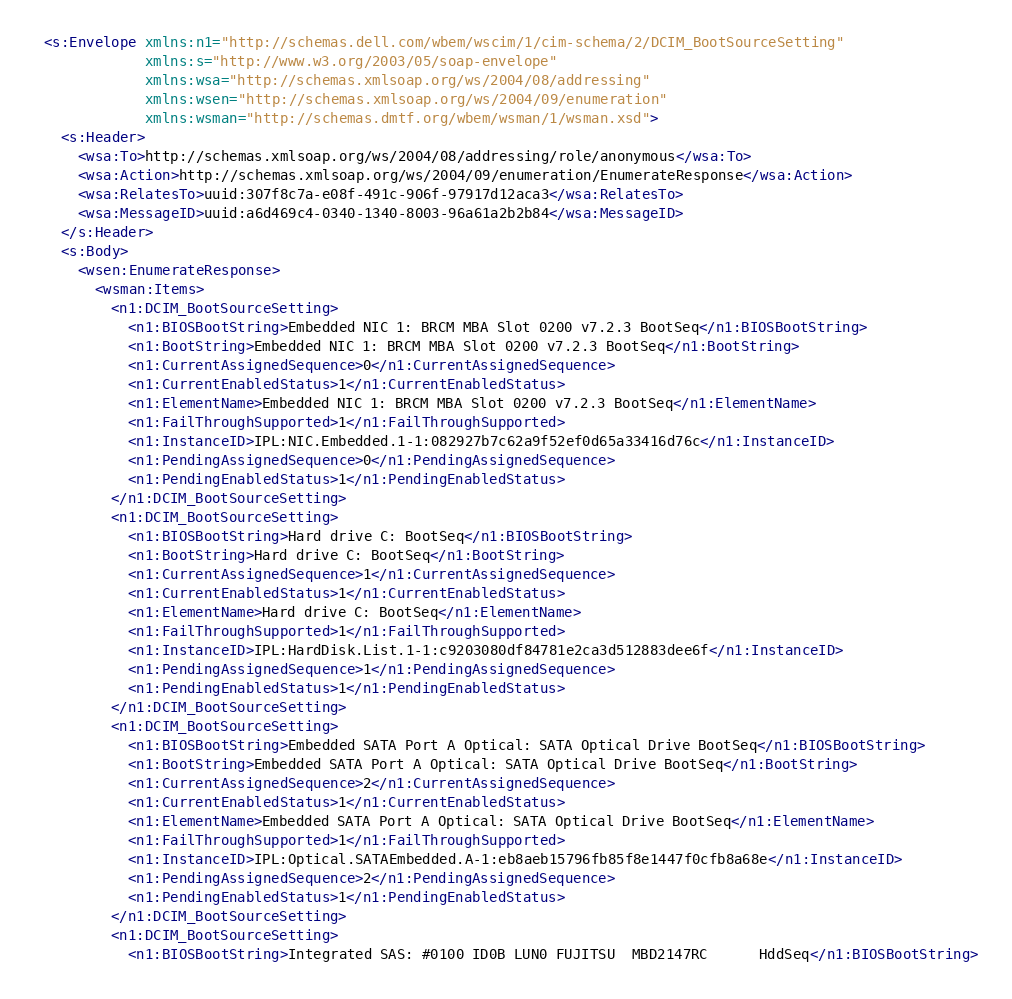<code> <loc_0><loc_0><loc_500><loc_500><_XML_><s:Envelope xmlns:n1="http://schemas.dell.com/wbem/wscim/1/cim-schema/2/DCIM_BootSourceSetting"
            xmlns:s="http://www.w3.org/2003/05/soap-envelope"
            xmlns:wsa="http://schemas.xmlsoap.org/ws/2004/08/addressing"
            xmlns:wsen="http://schemas.xmlsoap.org/ws/2004/09/enumeration"
            xmlns:wsman="http://schemas.dmtf.org/wbem/wsman/1/wsman.xsd">
  <s:Header>
    <wsa:To>http://schemas.xmlsoap.org/ws/2004/08/addressing/role/anonymous</wsa:To>
    <wsa:Action>http://schemas.xmlsoap.org/ws/2004/09/enumeration/EnumerateResponse</wsa:Action>
    <wsa:RelatesTo>uuid:307f8c7a-e08f-491c-906f-97917d12aca3</wsa:RelatesTo>
    <wsa:MessageID>uuid:a6d469c4-0340-1340-8003-96a61a2b2b84</wsa:MessageID>
  </s:Header>
  <s:Body>
    <wsen:EnumerateResponse>
      <wsman:Items>
        <n1:DCIM_BootSourceSetting>
          <n1:BIOSBootString>Embedded NIC 1: BRCM MBA Slot 0200 v7.2.3 BootSeq</n1:BIOSBootString>
          <n1:BootString>Embedded NIC 1: BRCM MBA Slot 0200 v7.2.3 BootSeq</n1:BootString>
          <n1:CurrentAssignedSequence>0</n1:CurrentAssignedSequence>
          <n1:CurrentEnabledStatus>1</n1:CurrentEnabledStatus>
          <n1:ElementName>Embedded NIC 1: BRCM MBA Slot 0200 v7.2.3 BootSeq</n1:ElementName>
          <n1:FailThroughSupported>1</n1:FailThroughSupported>
          <n1:InstanceID>IPL:NIC.Embedded.1-1:082927b7c62a9f52ef0d65a33416d76c</n1:InstanceID>
          <n1:PendingAssignedSequence>0</n1:PendingAssignedSequence>
          <n1:PendingEnabledStatus>1</n1:PendingEnabledStatus>
        </n1:DCIM_BootSourceSetting>
        <n1:DCIM_BootSourceSetting>
          <n1:BIOSBootString>Hard drive C: BootSeq</n1:BIOSBootString>
          <n1:BootString>Hard drive C: BootSeq</n1:BootString>
          <n1:CurrentAssignedSequence>1</n1:CurrentAssignedSequence>
          <n1:CurrentEnabledStatus>1</n1:CurrentEnabledStatus>
          <n1:ElementName>Hard drive C: BootSeq</n1:ElementName>
          <n1:FailThroughSupported>1</n1:FailThroughSupported>
          <n1:InstanceID>IPL:HardDisk.List.1-1:c9203080df84781e2ca3d512883dee6f</n1:InstanceID>
          <n1:PendingAssignedSequence>1</n1:PendingAssignedSequence>
          <n1:PendingEnabledStatus>1</n1:PendingEnabledStatus>
        </n1:DCIM_BootSourceSetting>
        <n1:DCIM_BootSourceSetting>
          <n1:BIOSBootString>Embedded SATA Port A Optical: SATA Optical Drive BootSeq</n1:BIOSBootString>
          <n1:BootString>Embedded SATA Port A Optical: SATA Optical Drive BootSeq</n1:BootString>
          <n1:CurrentAssignedSequence>2</n1:CurrentAssignedSequence>
          <n1:CurrentEnabledStatus>1</n1:CurrentEnabledStatus>
          <n1:ElementName>Embedded SATA Port A Optical: SATA Optical Drive BootSeq</n1:ElementName>
          <n1:FailThroughSupported>1</n1:FailThroughSupported>
          <n1:InstanceID>IPL:Optical.SATAEmbedded.A-1:eb8aeb15796fb85f8e1447f0cfb8a68e</n1:InstanceID>
          <n1:PendingAssignedSequence>2</n1:PendingAssignedSequence>
          <n1:PendingEnabledStatus>1</n1:PendingEnabledStatus>
        </n1:DCIM_BootSourceSetting>
        <n1:DCIM_BootSourceSetting>
          <n1:BIOSBootString>Integrated SAS: #0100 ID0B LUN0 FUJITSU  MBD2147RC      HddSeq</n1:BIOSBootString></code> 